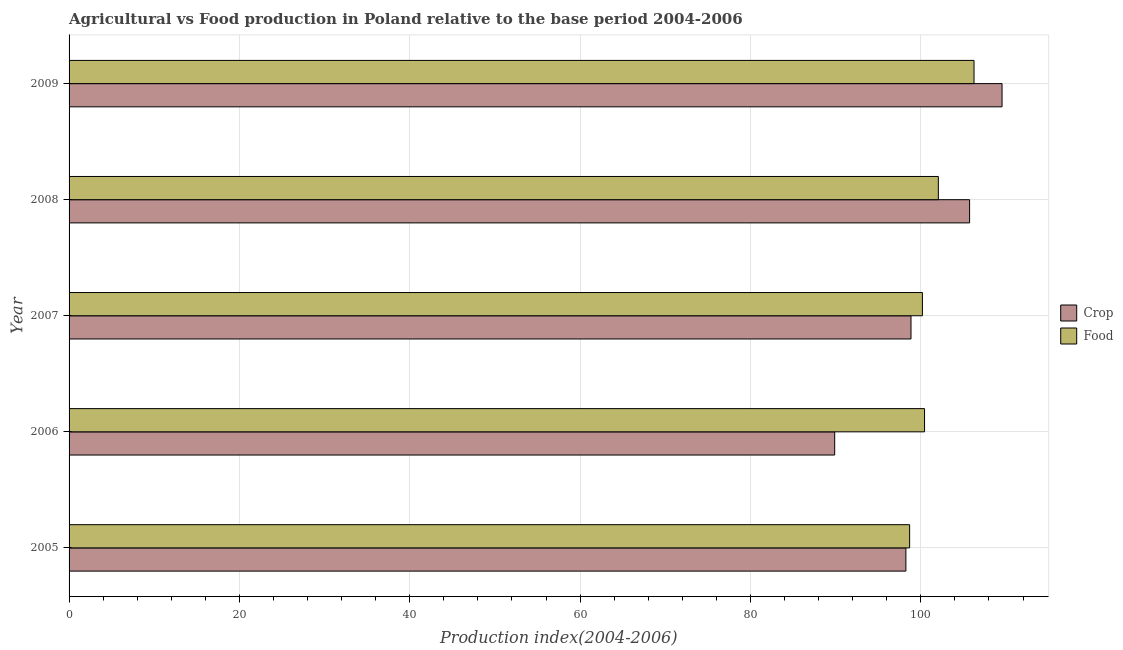How many different coloured bars are there?
Provide a short and direct response. 2. In how many cases, is the number of bars for a given year not equal to the number of legend labels?
Make the answer very short. 0. What is the food production index in 2006?
Give a very brief answer. 100.44. Across all years, what is the maximum crop production index?
Provide a short and direct response. 109.54. Across all years, what is the minimum food production index?
Your response must be concise. 98.69. In which year was the food production index maximum?
Your answer should be very brief. 2009. What is the total food production index in the graph?
Make the answer very short. 507.63. What is the difference between the crop production index in 2005 and that in 2008?
Provide a succinct answer. -7.48. What is the difference between the crop production index in 2009 and the food production index in 2006?
Offer a terse response. 9.1. What is the average food production index per year?
Keep it short and to the point. 101.53. In the year 2009, what is the difference between the food production index and crop production index?
Your answer should be very brief. -3.29. What is the ratio of the food production index in 2007 to that in 2009?
Ensure brevity in your answer.  0.94. Is the crop production index in 2005 less than that in 2009?
Provide a short and direct response. Yes. What is the difference between the highest and the second highest crop production index?
Provide a short and direct response. 3.81. What is the difference between the highest and the lowest crop production index?
Your answer should be very brief. 19.65. What does the 2nd bar from the top in 2007 represents?
Your answer should be compact. Crop. What does the 1st bar from the bottom in 2008 represents?
Make the answer very short. Crop. How many bars are there?
Your response must be concise. 10. Are all the bars in the graph horizontal?
Give a very brief answer. Yes. How many years are there in the graph?
Offer a very short reply. 5. Does the graph contain any zero values?
Ensure brevity in your answer.  No. Where does the legend appear in the graph?
Keep it short and to the point. Center right. What is the title of the graph?
Provide a succinct answer. Agricultural vs Food production in Poland relative to the base period 2004-2006. What is the label or title of the X-axis?
Keep it short and to the point. Production index(2004-2006). What is the Production index(2004-2006) of Crop in 2005?
Your answer should be very brief. 98.25. What is the Production index(2004-2006) in Food in 2005?
Your response must be concise. 98.69. What is the Production index(2004-2006) of Crop in 2006?
Keep it short and to the point. 89.89. What is the Production index(2004-2006) in Food in 2006?
Ensure brevity in your answer.  100.44. What is the Production index(2004-2006) of Crop in 2007?
Keep it short and to the point. 98.85. What is the Production index(2004-2006) of Food in 2007?
Give a very brief answer. 100.19. What is the Production index(2004-2006) of Crop in 2008?
Offer a terse response. 105.73. What is the Production index(2004-2006) in Food in 2008?
Provide a succinct answer. 102.06. What is the Production index(2004-2006) of Crop in 2009?
Keep it short and to the point. 109.54. What is the Production index(2004-2006) of Food in 2009?
Offer a terse response. 106.25. Across all years, what is the maximum Production index(2004-2006) in Crop?
Offer a very short reply. 109.54. Across all years, what is the maximum Production index(2004-2006) of Food?
Provide a short and direct response. 106.25. Across all years, what is the minimum Production index(2004-2006) of Crop?
Provide a short and direct response. 89.89. Across all years, what is the minimum Production index(2004-2006) in Food?
Make the answer very short. 98.69. What is the total Production index(2004-2006) in Crop in the graph?
Ensure brevity in your answer.  502.26. What is the total Production index(2004-2006) in Food in the graph?
Keep it short and to the point. 507.63. What is the difference between the Production index(2004-2006) in Crop in 2005 and that in 2006?
Give a very brief answer. 8.36. What is the difference between the Production index(2004-2006) in Food in 2005 and that in 2006?
Provide a short and direct response. -1.75. What is the difference between the Production index(2004-2006) of Food in 2005 and that in 2007?
Ensure brevity in your answer.  -1.5. What is the difference between the Production index(2004-2006) in Crop in 2005 and that in 2008?
Give a very brief answer. -7.48. What is the difference between the Production index(2004-2006) of Food in 2005 and that in 2008?
Keep it short and to the point. -3.37. What is the difference between the Production index(2004-2006) of Crop in 2005 and that in 2009?
Provide a succinct answer. -11.29. What is the difference between the Production index(2004-2006) in Food in 2005 and that in 2009?
Offer a terse response. -7.56. What is the difference between the Production index(2004-2006) in Crop in 2006 and that in 2007?
Give a very brief answer. -8.96. What is the difference between the Production index(2004-2006) of Crop in 2006 and that in 2008?
Give a very brief answer. -15.84. What is the difference between the Production index(2004-2006) of Food in 2006 and that in 2008?
Your response must be concise. -1.62. What is the difference between the Production index(2004-2006) in Crop in 2006 and that in 2009?
Ensure brevity in your answer.  -19.65. What is the difference between the Production index(2004-2006) in Food in 2006 and that in 2009?
Make the answer very short. -5.81. What is the difference between the Production index(2004-2006) in Crop in 2007 and that in 2008?
Offer a terse response. -6.88. What is the difference between the Production index(2004-2006) of Food in 2007 and that in 2008?
Your answer should be very brief. -1.87. What is the difference between the Production index(2004-2006) in Crop in 2007 and that in 2009?
Keep it short and to the point. -10.69. What is the difference between the Production index(2004-2006) of Food in 2007 and that in 2009?
Offer a terse response. -6.06. What is the difference between the Production index(2004-2006) in Crop in 2008 and that in 2009?
Keep it short and to the point. -3.81. What is the difference between the Production index(2004-2006) of Food in 2008 and that in 2009?
Provide a succinct answer. -4.19. What is the difference between the Production index(2004-2006) of Crop in 2005 and the Production index(2004-2006) of Food in 2006?
Offer a terse response. -2.19. What is the difference between the Production index(2004-2006) of Crop in 2005 and the Production index(2004-2006) of Food in 2007?
Give a very brief answer. -1.94. What is the difference between the Production index(2004-2006) in Crop in 2005 and the Production index(2004-2006) in Food in 2008?
Offer a very short reply. -3.81. What is the difference between the Production index(2004-2006) in Crop in 2006 and the Production index(2004-2006) in Food in 2007?
Your answer should be compact. -10.3. What is the difference between the Production index(2004-2006) in Crop in 2006 and the Production index(2004-2006) in Food in 2008?
Ensure brevity in your answer.  -12.17. What is the difference between the Production index(2004-2006) in Crop in 2006 and the Production index(2004-2006) in Food in 2009?
Offer a terse response. -16.36. What is the difference between the Production index(2004-2006) in Crop in 2007 and the Production index(2004-2006) in Food in 2008?
Offer a terse response. -3.21. What is the difference between the Production index(2004-2006) of Crop in 2007 and the Production index(2004-2006) of Food in 2009?
Your response must be concise. -7.4. What is the difference between the Production index(2004-2006) of Crop in 2008 and the Production index(2004-2006) of Food in 2009?
Give a very brief answer. -0.52. What is the average Production index(2004-2006) of Crop per year?
Ensure brevity in your answer.  100.45. What is the average Production index(2004-2006) in Food per year?
Provide a succinct answer. 101.53. In the year 2005, what is the difference between the Production index(2004-2006) of Crop and Production index(2004-2006) of Food?
Your answer should be compact. -0.44. In the year 2006, what is the difference between the Production index(2004-2006) of Crop and Production index(2004-2006) of Food?
Provide a succinct answer. -10.55. In the year 2007, what is the difference between the Production index(2004-2006) in Crop and Production index(2004-2006) in Food?
Your answer should be very brief. -1.34. In the year 2008, what is the difference between the Production index(2004-2006) of Crop and Production index(2004-2006) of Food?
Your answer should be very brief. 3.67. In the year 2009, what is the difference between the Production index(2004-2006) of Crop and Production index(2004-2006) of Food?
Give a very brief answer. 3.29. What is the ratio of the Production index(2004-2006) of Crop in 2005 to that in 2006?
Offer a terse response. 1.09. What is the ratio of the Production index(2004-2006) of Food in 2005 to that in 2006?
Your answer should be very brief. 0.98. What is the ratio of the Production index(2004-2006) of Crop in 2005 to that in 2008?
Provide a short and direct response. 0.93. What is the ratio of the Production index(2004-2006) of Food in 2005 to that in 2008?
Your response must be concise. 0.97. What is the ratio of the Production index(2004-2006) in Crop in 2005 to that in 2009?
Your answer should be very brief. 0.9. What is the ratio of the Production index(2004-2006) in Food in 2005 to that in 2009?
Provide a short and direct response. 0.93. What is the ratio of the Production index(2004-2006) in Crop in 2006 to that in 2007?
Make the answer very short. 0.91. What is the ratio of the Production index(2004-2006) of Crop in 2006 to that in 2008?
Keep it short and to the point. 0.85. What is the ratio of the Production index(2004-2006) in Food in 2006 to that in 2008?
Provide a short and direct response. 0.98. What is the ratio of the Production index(2004-2006) in Crop in 2006 to that in 2009?
Offer a terse response. 0.82. What is the ratio of the Production index(2004-2006) of Food in 2006 to that in 2009?
Provide a short and direct response. 0.95. What is the ratio of the Production index(2004-2006) of Crop in 2007 to that in 2008?
Offer a terse response. 0.93. What is the ratio of the Production index(2004-2006) of Food in 2007 to that in 2008?
Give a very brief answer. 0.98. What is the ratio of the Production index(2004-2006) in Crop in 2007 to that in 2009?
Provide a succinct answer. 0.9. What is the ratio of the Production index(2004-2006) of Food in 2007 to that in 2009?
Your answer should be compact. 0.94. What is the ratio of the Production index(2004-2006) in Crop in 2008 to that in 2009?
Your response must be concise. 0.97. What is the ratio of the Production index(2004-2006) in Food in 2008 to that in 2009?
Provide a short and direct response. 0.96. What is the difference between the highest and the second highest Production index(2004-2006) in Crop?
Make the answer very short. 3.81. What is the difference between the highest and the second highest Production index(2004-2006) in Food?
Provide a short and direct response. 4.19. What is the difference between the highest and the lowest Production index(2004-2006) of Crop?
Your answer should be very brief. 19.65. What is the difference between the highest and the lowest Production index(2004-2006) of Food?
Your answer should be very brief. 7.56. 